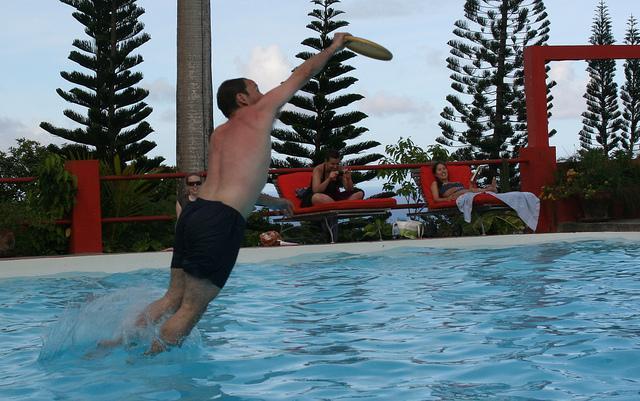Where is the man while he is swimming?
From the following set of four choices, select the accurate answer to respond to the question.
Options: In ocean, in pool, in river, in lake. In pool. 